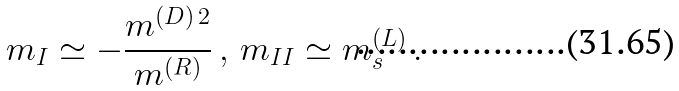Convert formula to latex. <formula><loc_0><loc_0><loc_500><loc_500>m _ { I } \simeq - \frac { m ^ { ( D ) \, 2 } } { m ^ { ( R ) } } \, , \, m _ { I I } \simeq m ^ { ( L ) } _ { s } \, .</formula> 